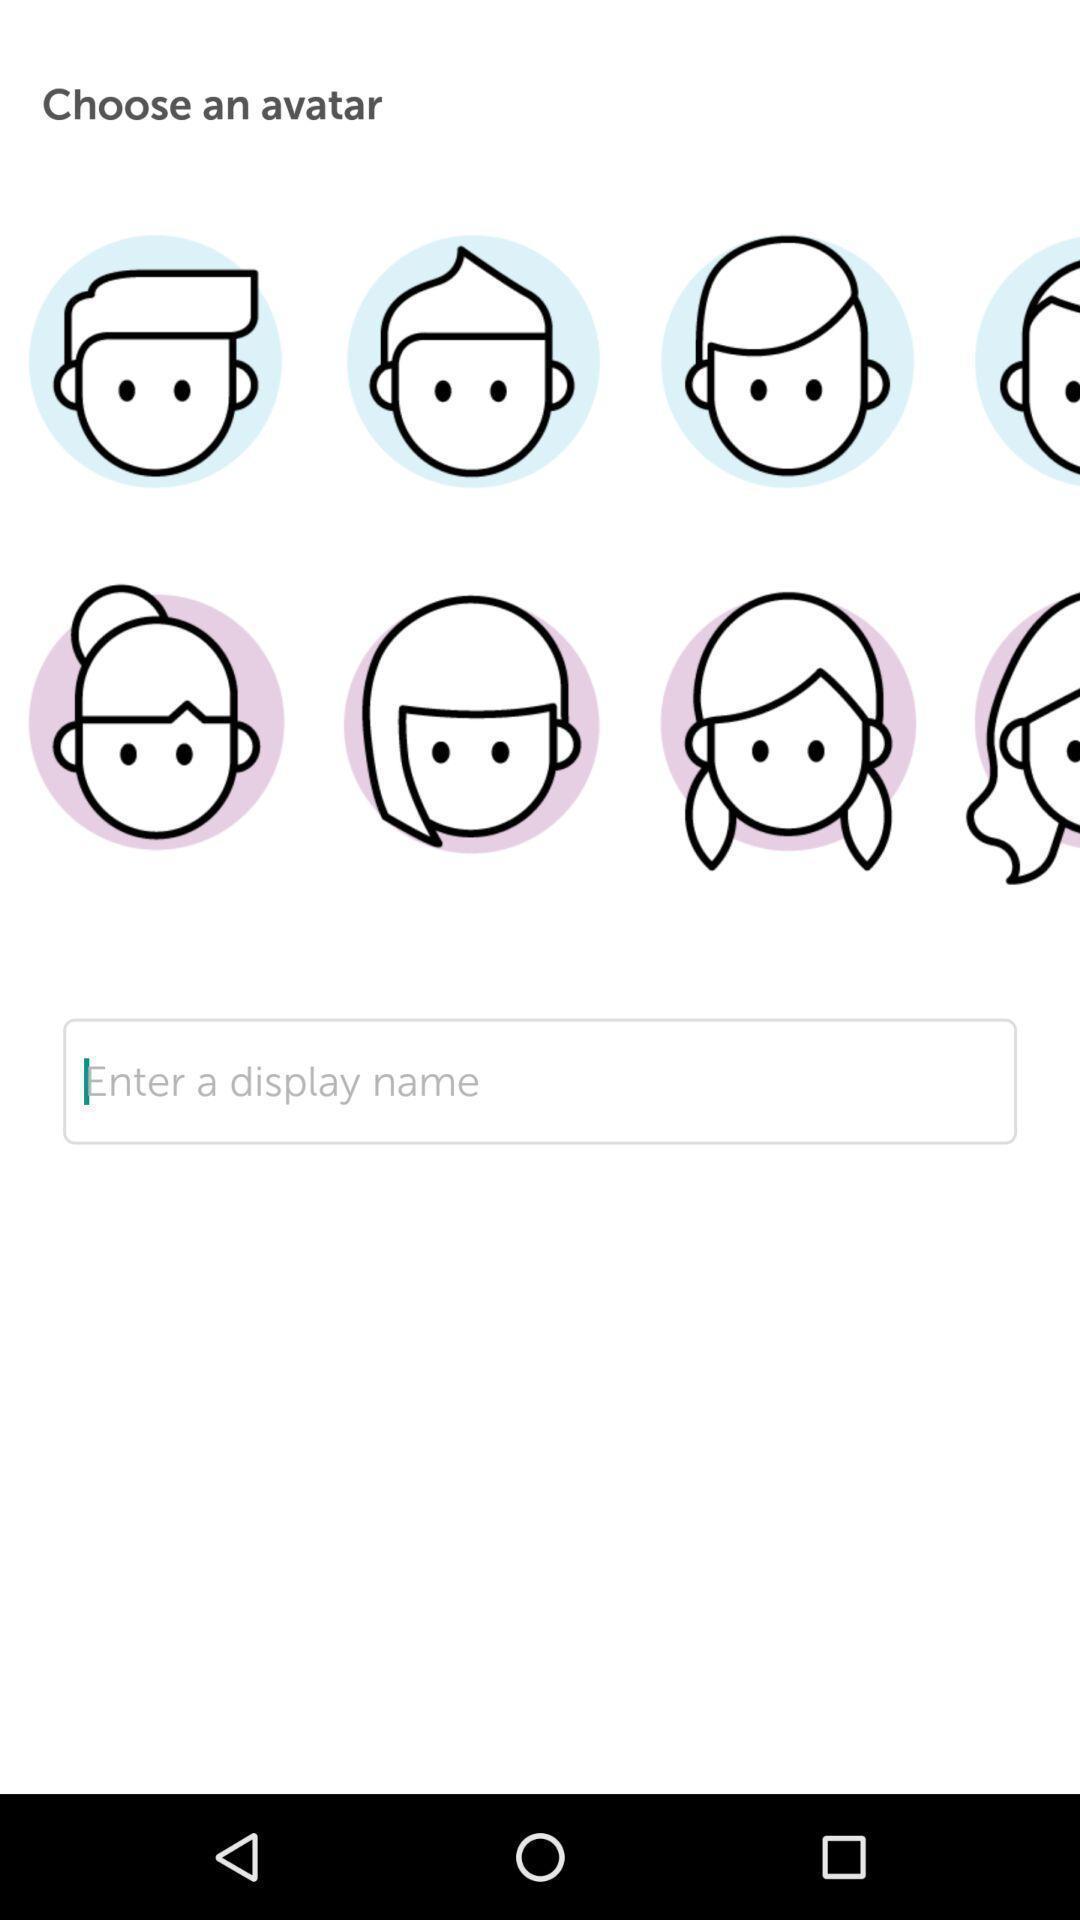Summarize the main components in this picture. Screen displaying the list of avatars. 